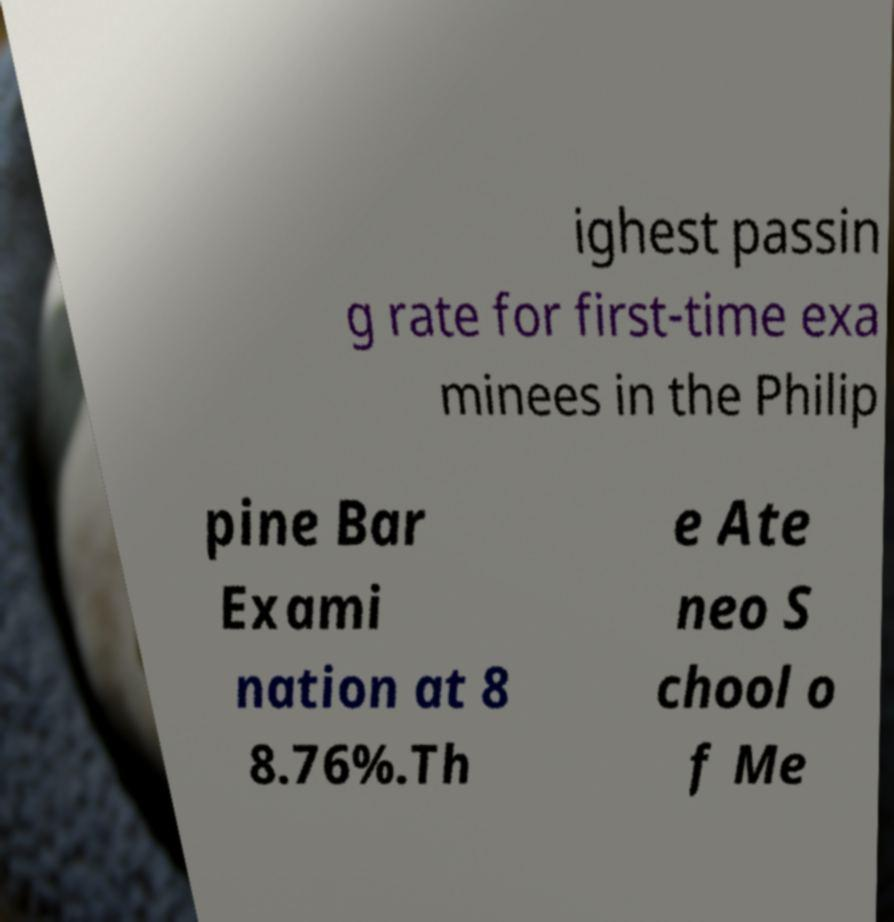Can you read and provide the text displayed in the image?This photo seems to have some interesting text. Can you extract and type it out for me? ighest passin g rate for first-time exa minees in the Philip pine Bar Exami nation at 8 8.76%.Th e Ate neo S chool o f Me 